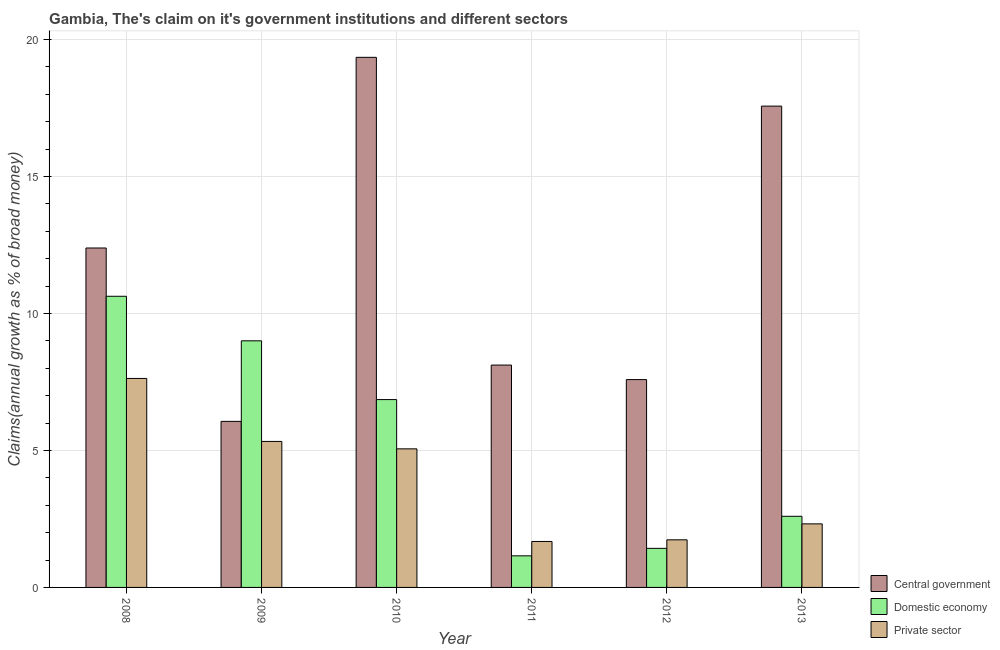How many different coloured bars are there?
Ensure brevity in your answer.  3. Are the number of bars on each tick of the X-axis equal?
Offer a terse response. Yes. How many bars are there on the 6th tick from the left?
Your response must be concise. 3. How many bars are there on the 4th tick from the right?
Keep it short and to the point. 3. In how many cases, is the number of bars for a given year not equal to the number of legend labels?
Provide a succinct answer. 0. What is the percentage of claim on the domestic economy in 2010?
Offer a very short reply. 6.86. Across all years, what is the maximum percentage of claim on the domestic economy?
Your answer should be compact. 10.63. Across all years, what is the minimum percentage of claim on the central government?
Provide a succinct answer. 6.06. In which year was the percentage of claim on the private sector maximum?
Offer a very short reply. 2008. What is the total percentage of claim on the central government in the graph?
Offer a terse response. 71.07. What is the difference between the percentage of claim on the private sector in 2009 and that in 2010?
Offer a terse response. 0.27. What is the difference between the percentage of claim on the private sector in 2010 and the percentage of claim on the domestic economy in 2012?
Your answer should be very brief. 3.32. What is the average percentage of claim on the central government per year?
Give a very brief answer. 11.85. What is the ratio of the percentage of claim on the domestic economy in 2008 to that in 2010?
Keep it short and to the point. 1.55. What is the difference between the highest and the second highest percentage of claim on the central government?
Provide a succinct answer. 1.78. What is the difference between the highest and the lowest percentage of claim on the private sector?
Keep it short and to the point. 5.95. In how many years, is the percentage of claim on the central government greater than the average percentage of claim on the central government taken over all years?
Give a very brief answer. 3. What does the 2nd bar from the left in 2012 represents?
Make the answer very short. Domestic economy. What does the 2nd bar from the right in 2013 represents?
Provide a succinct answer. Domestic economy. Is it the case that in every year, the sum of the percentage of claim on the central government and percentage of claim on the domestic economy is greater than the percentage of claim on the private sector?
Offer a very short reply. Yes. How many bars are there?
Your answer should be compact. 18. Are all the bars in the graph horizontal?
Keep it short and to the point. No. What is the difference between two consecutive major ticks on the Y-axis?
Your response must be concise. 5. Does the graph contain grids?
Your response must be concise. Yes. How many legend labels are there?
Keep it short and to the point. 3. What is the title of the graph?
Your answer should be compact. Gambia, The's claim on it's government institutions and different sectors. Does "Domestic" appear as one of the legend labels in the graph?
Your response must be concise. No. What is the label or title of the X-axis?
Offer a very short reply. Year. What is the label or title of the Y-axis?
Your answer should be compact. Claims(annual growth as % of broad money). What is the Claims(annual growth as % of broad money) of Central government in 2008?
Make the answer very short. 12.39. What is the Claims(annual growth as % of broad money) in Domestic economy in 2008?
Your response must be concise. 10.63. What is the Claims(annual growth as % of broad money) in Private sector in 2008?
Provide a short and direct response. 7.63. What is the Claims(annual growth as % of broad money) of Central government in 2009?
Keep it short and to the point. 6.06. What is the Claims(annual growth as % of broad money) of Domestic economy in 2009?
Provide a succinct answer. 9. What is the Claims(annual growth as % of broad money) in Private sector in 2009?
Ensure brevity in your answer.  5.33. What is the Claims(annual growth as % of broad money) in Central government in 2010?
Ensure brevity in your answer.  19.35. What is the Claims(annual growth as % of broad money) in Domestic economy in 2010?
Provide a succinct answer. 6.86. What is the Claims(annual growth as % of broad money) in Private sector in 2010?
Your answer should be compact. 5.06. What is the Claims(annual growth as % of broad money) in Central government in 2011?
Ensure brevity in your answer.  8.12. What is the Claims(annual growth as % of broad money) of Domestic economy in 2011?
Your answer should be compact. 1.15. What is the Claims(annual growth as % of broad money) of Private sector in 2011?
Your answer should be very brief. 1.68. What is the Claims(annual growth as % of broad money) of Central government in 2012?
Offer a terse response. 7.59. What is the Claims(annual growth as % of broad money) in Domestic economy in 2012?
Your answer should be compact. 1.43. What is the Claims(annual growth as % of broad money) of Private sector in 2012?
Ensure brevity in your answer.  1.74. What is the Claims(annual growth as % of broad money) of Central government in 2013?
Your answer should be compact. 17.57. What is the Claims(annual growth as % of broad money) of Domestic economy in 2013?
Provide a short and direct response. 2.6. What is the Claims(annual growth as % of broad money) in Private sector in 2013?
Offer a terse response. 2.32. Across all years, what is the maximum Claims(annual growth as % of broad money) in Central government?
Offer a terse response. 19.35. Across all years, what is the maximum Claims(annual growth as % of broad money) of Domestic economy?
Offer a terse response. 10.63. Across all years, what is the maximum Claims(annual growth as % of broad money) in Private sector?
Make the answer very short. 7.63. Across all years, what is the minimum Claims(annual growth as % of broad money) of Central government?
Ensure brevity in your answer.  6.06. Across all years, what is the minimum Claims(annual growth as % of broad money) of Domestic economy?
Ensure brevity in your answer.  1.15. Across all years, what is the minimum Claims(annual growth as % of broad money) in Private sector?
Provide a short and direct response. 1.68. What is the total Claims(annual growth as % of broad money) in Central government in the graph?
Your response must be concise. 71.07. What is the total Claims(annual growth as % of broad money) of Domestic economy in the graph?
Provide a short and direct response. 31.66. What is the total Claims(annual growth as % of broad money) in Private sector in the graph?
Your answer should be compact. 23.75. What is the difference between the Claims(annual growth as % of broad money) in Central government in 2008 and that in 2009?
Ensure brevity in your answer.  6.33. What is the difference between the Claims(annual growth as % of broad money) in Domestic economy in 2008 and that in 2009?
Make the answer very short. 1.63. What is the difference between the Claims(annual growth as % of broad money) of Private sector in 2008 and that in 2009?
Ensure brevity in your answer.  2.3. What is the difference between the Claims(annual growth as % of broad money) of Central government in 2008 and that in 2010?
Your answer should be compact. -6.96. What is the difference between the Claims(annual growth as % of broad money) of Domestic economy in 2008 and that in 2010?
Offer a very short reply. 3.77. What is the difference between the Claims(annual growth as % of broad money) in Private sector in 2008 and that in 2010?
Offer a terse response. 2.57. What is the difference between the Claims(annual growth as % of broad money) in Central government in 2008 and that in 2011?
Offer a terse response. 4.27. What is the difference between the Claims(annual growth as % of broad money) of Domestic economy in 2008 and that in 2011?
Keep it short and to the point. 9.47. What is the difference between the Claims(annual growth as % of broad money) in Private sector in 2008 and that in 2011?
Make the answer very short. 5.95. What is the difference between the Claims(annual growth as % of broad money) in Central government in 2008 and that in 2012?
Provide a succinct answer. 4.8. What is the difference between the Claims(annual growth as % of broad money) in Domestic economy in 2008 and that in 2012?
Offer a very short reply. 9.2. What is the difference between the Claims(annual growth as % of broad money) of Private sector in 2008 and that in 2012?
Your answer should be very brief. 5.89. What is the difference between the Claims(annual growth as % of broad money) of Central government in 2008 and that in 2013?
Your answer should be compact. -5.18. What is the difference between the Claims(annual growth as % of broad money) of Domestic economy in 2008 and that in 2013?
Make the answer very short. 8.03. What is the difference between the Claims(annual growth as % of broad money) in Private sector in 2008 and that in 2013?
Make the answer very short. 5.31. What is the difference between the Claims(annual growth as % of broad money) in Central government in 2009 and that in 2010?
Your response must be concise. -13.29. What is the difference between the Claims(annual growth as % of broad money) of Domestic economy in 2009 and that in 2010?
Keep it short and to the point. 2.15. What is the difference between the Claims(annual growth as % of broad money) of Private sector in 2009 and that in 2010?
Offer a terse response. 0.27. What is the difference between the Claims(annual growth as % of broad money) of Central government in 2009 and that in 2011?
Your answer should be very brief. -2.06. What is the difference between the Claims(annual growth as % of broad money) in Domestic economy in 2009 and that in 2011?
Ensure brevity in your answer.  7.85. What is the difference between the Claims(annual growth as % of broad money) in Private sector in 2009 and that in 2011?
Keep it short and to the point. 3.65. What is the difference between the Claims(annual growth as % of broad money) in Central government in 2009 and that in 2012?
Your response must be concise. -1.53. What is the difference between the Claims(annual growth as % of broad money) in Domestic economy in 2009 and that in 2012?
Provide a succinct answer. 7.58. What is the difference between the Claims(annual growth as % of broad money) in Private sector in 2009 and that in 2012?
Offer a very short reply. 3.59. What is the difference between the Claims(annual growth as % of broad money) of Central government in 2009 and that in 2013?
Make the answer very short. -11.51. What is the difference between the Claims(annual growth as % of broad money) in Domestic economy in 2009 and that in 2013?
Ensure brevity in your answer.  6.41. What is the difference between the Claims(annual growth as % of broad money) in Private sector in 2009 and that in 2013?
Your response must be concise. 3.01. What is the difference between the Claims(annual growth as % of broad money) of Central government in 2010 and that in 2011?
Ensure brevity in your answer.  11.23. What is the difference between the Claims(annual growth as % of broad money) of Domestic economy in 2010 and that in 2011?
Offer a terse response. 5.7. What is the difference between the Claims(annual growth as % of broad money) in Private sector in 2010 and that in 2011?
Keep it short and to the point. 3.38. What is the difference between the Claims(annual growth as % of broad money) of Central government in 2010 and that in 2012?
Your answer should be very brief. 11.76. What is the difference between the Claims(annual growth as % of broad money) of Domestic economy in 2010 and that in 2012?
Your answer should be compact. 5.43. What is the difference between the Claims(annual growth as % of broad money) of Private sector in 2010 and that in 2012?
Make the answer very short. 3.32. What is the difference between the Claims(annual growth as % of broad money) of Central government in 2010 and that in 2013?
Your response must be concise. 1.78. What is the difference between the Claims(annual growth as % of broad money) of Domestic economy in 2010 and that in 2013?
Your response must be concise. 4.26. What is the difference between the Claims(annual growth as % of broad money) in Private sector in 2010 and that in 2013?
Offer a very short reply. 2.74. What is the difference between the Claims(annual growth as % of broad money) in Central government in 2011 and that in 2012?
Offer a very short reply. 0.53. What is the difference between the Claims(annual growth as % of broad money) in Domestic economy in 2011 and that in 2012?
Your answer should be very brief. -0.27. What is the difference between the Claims(annual growth as % of broad money) in Private sector in 2011 and that in 2012?
Ensure brevity in your answer.  -0.06. What is the difference between the Claims(annual growth as % of broad money) of Central government in 2011 and that in 2013?
Provide a short and direct response. -9.45. What is the difference between the Claims(annual growth as % of broad money) in Domestic economy in 2011 and that in 2013?
Offer a very short reply. -1.44. What is the difference between the Claims(annual growth as % of broad money) of Private sector in 2011 and that in 2013?
Make the answer very short. -0.64. What is the difference between the Claims(annual growth as % of broad money) in Central government in 2012 and that in 2013?
Keep it short and to the point. -9.98. What is the difference between the Claims(annual growth as % of broad money) of Domestic economy in 2012 and that in 2013?
Your response must be concise. -1.17. What is the difference between the Claims(annual growth as % of broad money) in Private sector in 2012 and that in 2013?
Provide a short and direct response. -0.58. What is the difference between the Claims(annual growth as % of broad money) in Central government in 2008 and the Claims(annual growth as % of broad money) in Domestic economy in 2009?
Provide a short and direct response. 3.39. What is the difference between the Claims(annual growth as % of broad money) of Central government in 2008 and the Claims(annual growth as % of broad money) of Private sector in 2009?
Offer a terse response. 7.06. What is the difference between the Claims(annual growth as % of broad money) in Domestic economy in 2008 and the Claims(annual growth as % of broad money) in Private sector in 2009?
Make the answer very short. 5.3. What is the difference between the Claims(annual growth as % of broad money) of Central government in 2008 and the Claims(annual growth as % of broad money) of Domestic economy in 2010?
Give a very brief answer. 5.53. What is the difference between the Claims(annual growth as % of broad money) of Central government in 2008 and the Claims(annual growth as % of broad money) of Private sector in 2010?
Your answer should be compact. 7.33. What is the difference between the Claims(annual growth as % of broad money) in Domestic economy in 2008 and the Claims(annual growth as % of broad money) in Private sector in 2010?
Provide a succinct answer. 5.57. What is the difference between the Claims(annual growth as % of broad money) of Central government in 2008 and the Claims(annual growth as % of broad money) of Domestic economy in 2011?
Your response must be concise. 11.24. What is the difference between the Claims(annual growth as % of broad money) in Central government in 2008 and the Claims(annual growth as % of broad money) in Private sector in 2011?
Your answer should be compact. 10.71. What is the difference between the Claims(annual growth as % of broad money) of Domestic economy in 2008 and the Claims(annual growth as % of broad money) of Private sector in 2011?
Your answer should be compact. 8.95. What is the difference between the Claims(annual growth as % of broad money) of Central government in 2008 and the Claims(annual growth as % of broad money) of Domestic economy in 2012?
Your answer should be compact. 10.96. What is the difference between the Claims(annual growth as % of broad money) of Central government in 2008 and the Claims(annual growth as % of broad money) of Private sector in 2012?
Offer a terse response. 10.65. What is the difference between the Claims(annual growth as % of broad money) of Domestic economy in 2008 and the Claims(annual growth as % of broad money) of Private sector in 2012?
Keep it short and to the point. 8.89. What is the difference between the Claims(annual growth as % of broad money) of Central government in 2008 and the Claims(annual growth as % of broad money) of Domestic economy in 2013?
Provide a succinct answer. 9.79. What is the difference between the Claims(annual growth as % of broad money) in Central government in 2008 and the Claims(annual growth as % of broad money) in Private sector in 2013?
Offer a very short reply. 10.07. What is the difference between the Claims(annual growth as % of broad money) of Domestic economy in 2008 and the Claims(annual growth as % of broad money) of Private sector in 2013?
Keep it short and to the point. 8.31. What is the difference between the Claims(annual growth as % of broad money) in Central government in 2009 and the Claims(annual growth as % of broad money) in Domestic economy in 2010?
Your answer should be very brief. -0.79. What is the difference between the Claims(annual growth as % of broad money) in Central government in 2009 and the Claims(annual growth as % of broad money) in Private sector in 2010?
Your answer should be compact. 1. What is the difference between the Claims(annual growth as % of broad money) in Domestic economy in 2009 and the Claims(annual growth as % of broad money) in Private sector in 2010?
Offer a terse response. 3.94. What is the difference between the Claims(annual growth as % of broad money) in Central government in 2009 and the Claims(annual growth as % of broad money) in Domestic economy in 2011?
Ensure brevity in your answer.  4.91. What is the difference between the Claims(annual growth as % of broad money) of Central government in 2009 and the Claims(annual growth as % of broad money) of Private sector in 2011?
Provide a succinct answer. 4.38. What is the difference between the Claims(annual growth as % of broad money) of Domestic economy in 2009 and the Claims(annual growth as % of broad money) of Private sector in 2011?
Provide a short and direct response. 7.32. What is the difference between the Claims(annual growth as % of broad money) of Central government in 2009 and the Claims(annual growth as % of broad money) of Domestic economy in 2012?
Your answer should be compact. 4.64. What is the difference between the Claims(annual growth as % of broad money) of Central government in 2009 and the Claims(annual growth as % of broad money) of Private sector in 2012?
Your answer should be very brief. 4.32. What is the difference between the Claims(annual growth as % of broad money) of Domestic economy in 2009 and the Claims(annual growth as % of broad money) of Private sector in 2012?
Offer a terse response. 7.26. What is the difference between the Claims(annual growth as % of broad money) of Central government in 2009 and the Claims(annual growth as % of broad money) of Domestic economy in 2013?
Ensure brevity in your answer.  3.47. What is the difference between the Claims(annual growth as % of broad money) in Central government in 2009 and the Claims(annual growth as % of broad money) in Private sector in 2013?
Your answer should be compact. 3.74. What is the difference between the Claims(annual growth as % of broad money) in Domestic economy in 2009 and the Claims(annual growth as % of broad money) in Private sector in 2013?
Offer a terse response. 6.68. What is the difference between the Claims(annual growth as % of broad money) in Central government in 2010 and the Claims(annual growth as % of broad money) in Domestic economy in 2011?
Your answer should be compact. 18.2. What is the difference between the Claims(annual growth as % of broad money) of Central government in 2010 and the Claims(annual growth as % of broad money) of Private sector in 2011?
Keep it short and to the point. 17.67. What is the difference between the Claims(annual growth as % of broad money) of Domestic economy in 2010 and the Claims(annual growth as % of broad money) of Private sector in 2011?
Your answer should be very brief. 5.18. What is the difference between the Claims(annual growth as % of broad money) in Central government in 2010 and the Claims(annual growth as % of broad money) in Domestic economy in 2012?
Your answer should be compact. 17.92. What is the difference between the Claims(annual growth as % of broad money) in Central government in 2010 and the Claims(annual growth as % of broad money) in Private sector in 2012?
Your answer should be very brief. 17.61. What is the difference between the Claims(annual growth as % of broad money) of Domestic economy in 2010 and the Claims(annual growth as % of broad money) of Private sector in 2012?
Offer a terse response. 5.12. What is the difference between the Claims(annual growth as % of broad money) of Central government in 2010 and the Claims(annual growth as % of broad money) of Domestic economy in 2013?
Provide a succinct answer. 16.75. What is the difference between the Claims(annual growth as % of broad money) in Central government in 2010 and the Claims(annual growth as % of broad money) in Private sector in 2013?
Your answer should be very brief. 17.03. What is the difference between the Claims(annual growth as % of broad money) of Domestic economy in 2010 and the Claims(annual growth as % of broad money) of Private sector in 2013?
Provide a succinct answer. 4.54. What is the difference between the Claims(annual growth as % of broad money) of Central government in 2011 and the Claims(annual growth as % of broad money) of Domestic economy in 2012?
Offer a terse response. 6.69. What is the difference between the Claims(annual growth as % of broad money) of Central government in 2011 and the Claims(annual growth as % of broad money) of Private sector in 2012?
Provide a short and direct response. 6.38. What is the difference between the Claims(annual growth as % of broad money) in Domestic economy in 2011 and the Claims(annual growth as % of broad money) in Private sector in 2012?
Your answer should be very brief. -0.58. What is the difference between the Claims(annual growth as % of broad money) in Central government in 2011 and the Claims(annual growth as % of broad money) in Domestic economy in 2013?
Offer a terse response. 5.52. What is the difference between the Claims(annual growth as % of broad money) in Central government in 2011 and the Claims(annual growth as % of broad money) in Private sector in 2013?
Your answer should be compact. 5.8. What is the difference between the Claims(annual growth as % of broad money) of Domestic economy in 2011 and the Claims(annual growth as % of broad money) of Private sector in 2013?
Provide a succinct answer. -1.17. What is the difference between the Claims(annual growth as % of broad money) of Central government in 2012 and the Claims(annual growth as % of broad money) of Domestic economy in 2013?
Keep it short and to the point. 4.99. What is the difference between the Claims(annual growth as % of broad money) of Central government in 2012 and the Claims(annual growth as % of broad money) of Private sector in 2013?
Your response must be concise. 5.27. What is the difference between the Claims(annual growth as % of broad money) of Domestic economy in 2012 and the Claims(annual growth as % of broad money) of Private sector in 2013?
Give a very brief answer. -0.89. What is the average Claims(annual growth as % of broad money) in Central government per year?
Your response must be concise. 11.85. What is the average Claims(annual growth as % of broad money) in Domestic economy per year?
Keep it short and to the point. 5.28. What is the average Claims(annual growth as % of broad money) in Private sector per year?
Your answer should be very brief. 3.96. In the year 2008, what is the difference between the Claims(annual growth as % of broad money) in Central government and Claims(annual growth as % of broad money) in Domestic economy?
Provide a succinct answer. 1.76. In the year 2008, what is the difference between the Claims(annual growth as % of broad money) in Central government and Claims(annual growth as % of broad money) in Private sector?
Your answer should be compact. 4.76. In the year 2008, what is the difference between the Claims(annual growth as % of broad money) of Domestic economy and Claims(annual growth as % of broad money) of Private sector?
Your answer should be compact. 3. In the year 2009, what is the difference between the Claims(annual growth as % of broad money) in Central government and Claims(annual growth as % of broad money) in Domestic economy?
Your answer should be very brief. -2.94. In the year 2009, what is the difference between the Claims(annual growth as % of broad money) of Central government and Claims(annual growth as % of broad money) of Private sector?
Give a very brief answer. 0.73. In the year 2009, what is the difference between the Claims(annual growth as % of broad money) of Domestic economy and Claims(annual growth as % of broad money) of Private sector?
Keep it short and to the point. 3.67. In the year 2010, what is the difference between the Claims(annual growth as % of broad money) of Central government and Claims(annual growth as % of broad money) of Domestic economy?
Your answer should be compact. 12.49. In the year 2010, what is the difference between the Claims(annual growth as % of broad money) in Central government and Claims(annual growth as % of broad money) in Private sector?
Your answer should be compact. 14.29. In the year 2010, what is the difference between the Claims(annual growth as % of broad money) of Domestic economy and Claims(annual growth as % of broad money) of Private sector?
Ensure brevity in your answer.  1.8. In the year 2011, what is the difference between the Claims(annual growth as % of broad money) of Central government and Claims(annual growth as % of broad money) of Domestic economy?
Offer a very short reply. 6.96. In the year 2011, what is the difference between the Claims(annual growth as % of broad money) in Central government and Claims(annual growth as % of broad money) in Private sector?
Your answer should be very brief. 6.44. In the year 2011, what is the difference between the Claims(annual growth as % of broad money) of Domestic economy and Claims(annual growth as % of broad money) of Private sector?
Your answer should be very brief. -0.52. In the year 2012, what is the difference between the Claims(annual growth as % of broad money) of Central government and Claims(annual growth as % of broad money) of Domestic economy?
Make the answer very short. 6.16. In the year 2012, what is the difference between the Claims(annual growth as % of broad money) in Central government and Claims(annual growth as % of broad money) in Private sector?
Keep it short and to the point. 5.85. In the year 2012, what is the difference between the Claims(annual growth as % of broad money) of Domestic economy and Claims(annual growth as % of broad money) of Private sector?
Offer a terse response. -0.31. In the year 2013, what is the difference between the Claims(annual growth as % of broad money) of Central government and Claims(annual growth as % of broad money) of Domestic economy?
Your answer should be very brief. 14.97. In the year 2013, what is the difference between the Claims(annual growth as % of broad money) of Central government and Claims(annual growth as % of broad money) of Private sector?
Your answer should be very brief. 15.25. In the year 2013, what is the difference between the Claims(annual growth as % of broad money) of Domestic economy and Claims(annual growth as % of broad money) of Private sector?
Offer a terse response. 0.28. What is the ratio of the Claims(annual growth as % of broad money) of Central government in 2008 to that in 2009?
Make the answer very short. 2.04. What is the ratio of the Claims(annual growth as % of broad money) in Domestic economy in 2008 to that in 2009?
Your response must be concise. 1.18. What is the ratio of the Claims(annual growth as % of broad money) of Private sector in 2008 to that in 2009?
Your answer should be very brief. 1.43. What is the ratio of the Claims(annual growth as % of broad money) of Central government in 2008 to that in 2010?
Ensure brevity in your answer.  0.64. What is the ratio of the Claims(annual growth as % of broad money) in Domestic economy in 2008 to that in 2010?
Your answer should be very brief. 1.55. What is the ratio of the Claims(annual growth as % of broad money) of Private sector in 2008 to that in 2010?
Keep it short and to the point. 1.51. What is the ratio of the Claims(annual growth as % of broad money) in Central government in 2008 to that in 2011?
Make the answer very short. 1.53. What is the ratio of the Claims(annual growth as % of broad money) in Domestic economy in 2008 to that in 2011?
Give a very brief answer. 9.22. What is the ratio of the Claims(annual growth as % of broad money) of Private sector in 2008 to that in 2011?
Offer a terse response. 4.55. What is the ratio of the Claims(annual growth as % of broad money) in Central government in 2008 to that in 2012?
Your answer should be compact. 1.63. What is the ratio of the Claims(annual growth as % of broad money) of Domestic economy in 2008 to that in 2012?
Your response must be concise. 7.45. What is the ratio of the Claims(annual growth as % of broad money) of Private sector in 2008 to that in 2012?
Keep it short and to the point. 4.39. What is the ratio of the Claims(annual growth as % of broad money) of Central government in 2008 to that in 2013?
Ensure brevity in your answer.  0.71. What is the ratio of the Claims(annual growth as % of broad money) in Domestic economy in 2008 to that in 2013?
Offer a terse response. 4.09. What is the ratio of the Claims(annual growth as % of broad money) in Private sector in 2008 to that in 2013?
Your answer should be very brief. 3.29. What is the ratio of the Claims(annual growth as % of broad money) in Central government in 2009 to that in 2010?
Ensure brevity in your answer.  0.31. What is the ratio of the Claims(annual growth as % of broad money) of Domestic economy in 2009 to that in 2010?
Ensure brevity in your answer.  1.31. What is the ratio of the Claims(annual growth as % of broad money) of Private sector in 2009 to that in 2010?
Make the answer very short. 1.05. What is the ratio of the Claims(annual growth as % of broad money) in Central government in 2009 to that in 2011?
Give a very brief answer. 0.75. What is the ratio of the Claims(annual growth as % of broad money) in Domestic economy in 2009 to that in 2011?
Offer a terse response. 7.81. What is the ratio of the Claims(annual growth as % of broad money) of Private sector in 2009 to that in 2011?
Provide a short and direct response. 3.18. What is the ratio of the Claims(annual growth as % of broad money) in Central government in 2009 to that in 2012?
Make the answer very short. 0.8. What is the ratio of the Claims(annual growth as % of broad money) in Domestic economy in 2009 to that in 2012?
Your response must be concise. 6.31. What is the ratio of the Claims(annual growth as % of broad money) of Private sector in 2009 to that in 2012?
Offer a very short reply. 3.07. What is the ratio of the Claims(annual growth as % of broad money) of Central government in 2009 to that in 2013?
Give a very brief answer. 0.34. What is the ratio of the Claims(annual growth as % of broad money) of Domestic economy in 2009 to that in 2013?
Ensure brevity in your answer.  3.47. What is the ratio of the Claims(annual growth as % of broad money) in Private sector in 2009 to that in 2013?
Your response must be concise. 2.3. What is the ratio of the Claims(annual growth as % of broad money) of Central government in 2010 to that in 2011?
Make the answer very short. 2.38. What is the ratio of the Claims(annual growth as % of broad money) in Domestic economy in 2010 to that in 2011?
Give a very brief answer. 5.95. What is the ratio of the Claims(annual growth as % of broad money) in Private sector in 2010 to that in 2011?
Your answer should be compact. 3.02. What is the ratio of the Claims(annual growth as % of broad money) of Central government in 2010 to that in 2012?
Ensure brevity in your answer.  2.55. What is the ratio of the Claims(annual growth as % of broad money) of Domestic economy in 2010 to that in 2012?
Make the answer very short. 4.81. What is the ratio of the Claims(annual growth as % of broad money) in Private sector in 2010 to that in 2012?
Offer a very short reply. 2.91. What is the ratio of the Claims(annual growth as % of broad money) in Central government in 2010 to that in 2013?
Provide a short and direct response. 1.1. What is the ratio of the Claims(annual growth as % of broad money) in Domestic economy in 2010 to that in 2013?
Provide a succinct answer. 2.64. What is the ratio of the Claims(annual growth as % of broad money) in Private sector in 2010 to that in 2013?
Offer a very short reply. 2.18. What is the ratio of the Claims(annual growth as % of broad money) of Central government in 2011 to that in 2012?
Provide a succinct answer. 1.07. What is the ratio of the Claims(annual growth as % of broad money) in Domestic economy in 2011 to that in 2012?
Provide a short and direct response. 0.81. What is the ratio of the Claims(annual growth as % of broad money) in Private sector in 2011 to that in 2012?
Offer a terse response. 0.97. What is the ratio of the Claims(annual growth as % of broad money) of Central government in 2011 to that in 2013?
Your answer should be very brief. 0.46. What is the ratio of the Claims(annual growth as % of broad money) in Domestic economy in 2011 to that in 2013?
Provide a short and direct response. 0.44. What is the ratio of the Claims(annual growth as % of broad money) in Private sector in 2011 to that in 2013?
Your response must be concise. 0.72. What is the ratio of the Claims(annual growth as % of broad money) of Central government in 2012 to that in 2013?
Give a very brief answer. 0.43. What is the ratio of the Claims(annual growth as % of broad money) of Domestic economy in 2012 to that in 2013?
Provide a short and direct response. 0.55. What is the ratio of the Claims(annual growth as % of broad money) of Private sector in 2012 to that in 2013?
Your answer should be compact. 0.75. What is the difference between the highest and the second highest Claims(annual growth as % of broad money) of Central government?
Provide a short and direct response. 1.78. What is the difference between the highest and the second highest Claims(annual growth as % of broad money) in Domestic economy?
Ensure brevity in your answer.  1.63. What is the difference between the highest and the second highest Claims(annual growth as % of broad money) in Private sector?
Your answer should be very brief. 2.3. What is the difference between the highest and the lowest Claims(annual growth as % of broad money) in Central government?
Your response must be concise. 13.29. What is the difference between the highest and the lowest Claims(annual growth as % of broad money) in Domestic economy?
Keep it short and to the point. 9.47. What is the difference between the highest and the lowest Claims(annual growth as % of broad money) in Private sector?
Provide a short and direct response. 5.95. 